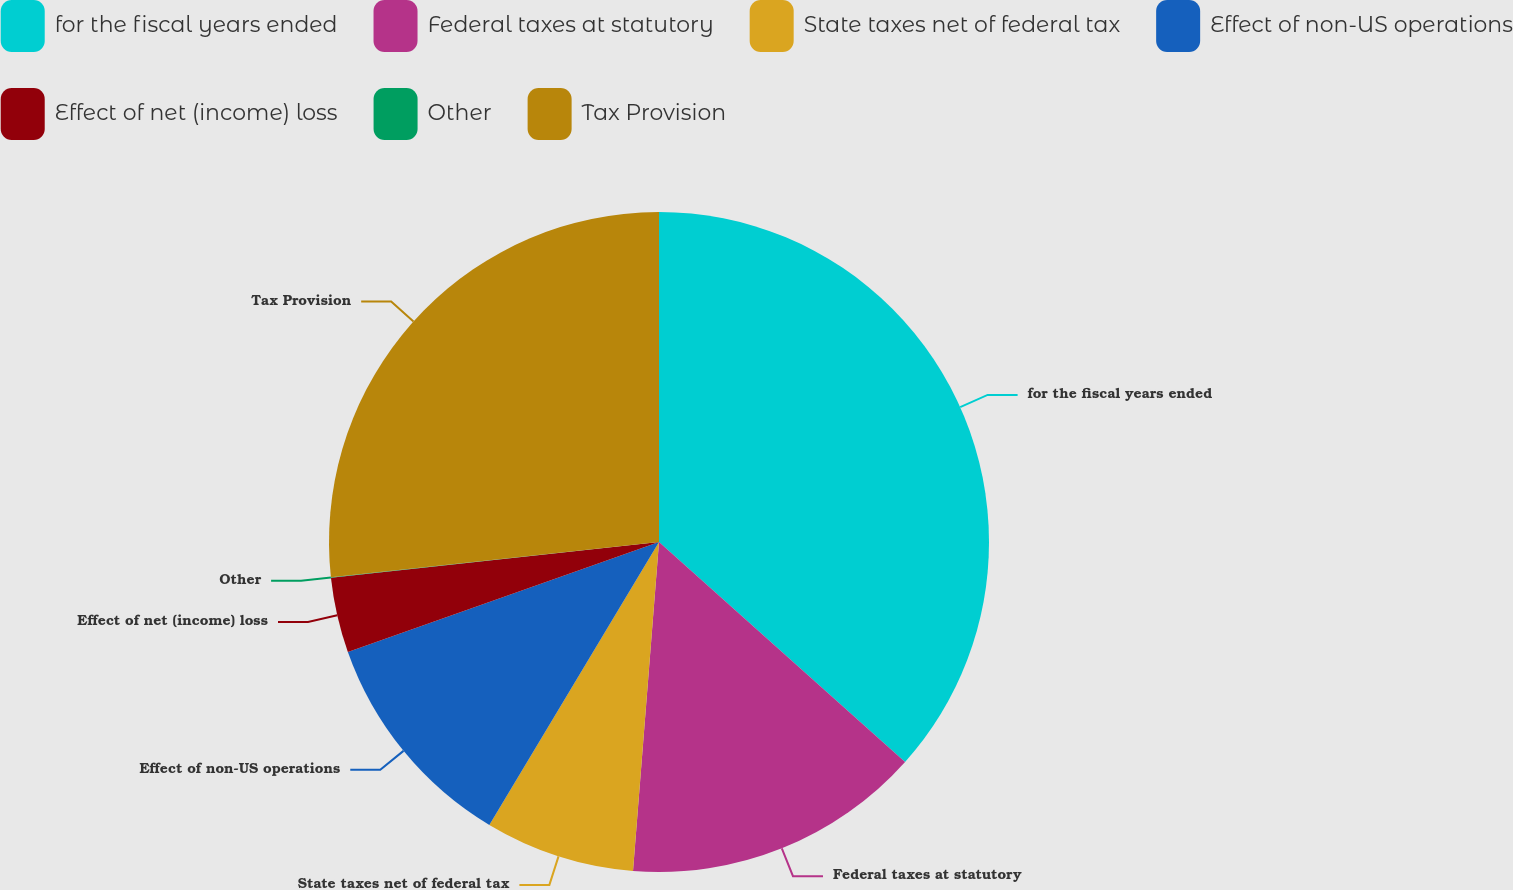<chart> <loc_0><loc_0><loc_500><loc_500><pie_chart><fcel>for the fiscal years ended<fcel>Federal taxes at statutory<fcel>State taxes net of federal tax<fcel>Effect of non-US operations<fcel>Effect of net (income) loss<fcel>Other<fcel>Tax Provision<nl><fcel>36.61%<fcel>14.65%<fcel>7.34%<fcel>11.0%<fcel>3.68%<fcel>0.02%<fcel>26.71%<nl></chart> 